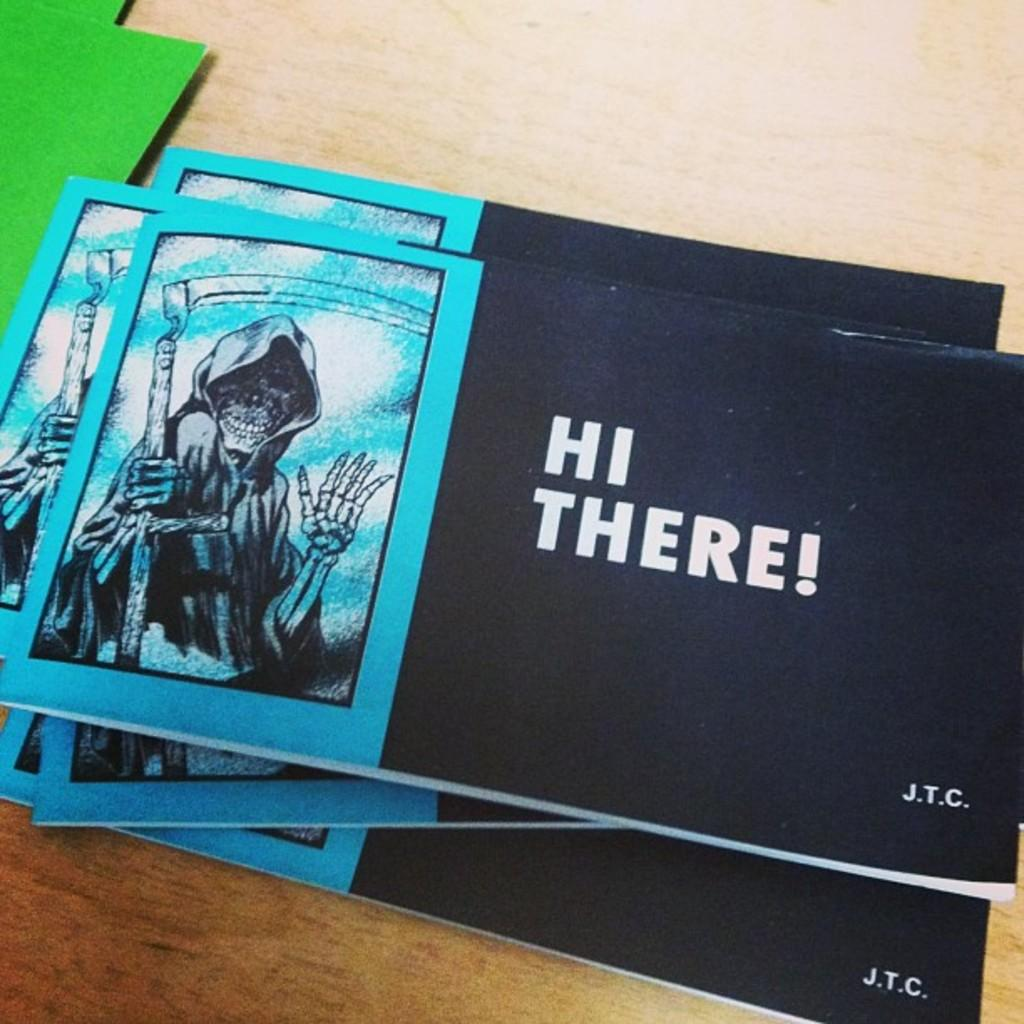<image>
Share a concise interpretation of the image provided. A blue and black booklet with a pic of the grim reaper on the left side and the other side is black with HI THERE! in bold white print. 